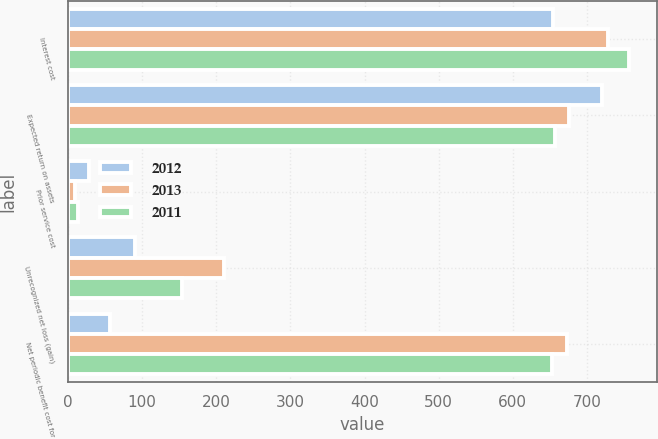Convert chart. <chart><loc_0><loc_0><loc_500><loc_500><stacked_bar_chart><ecel><fcel>Interest cost<fcel>Expected return on assets<fcel>Prior service cost<fcel>Unrecognized net loss (gain)<fcel>Net periodic benefit cost for<nl><fcel>2012<fcel>654<fcel>720<fcel>28<fcel>90<fcel>56<nl><fcel>2013<fcel>729<fcel>676<fcel>10<fcel>211<fcel>673<nl><fcel>2011<fcel>757<fcel>657<fcel>13<fcel>154<fcel>653<nl></chart> 